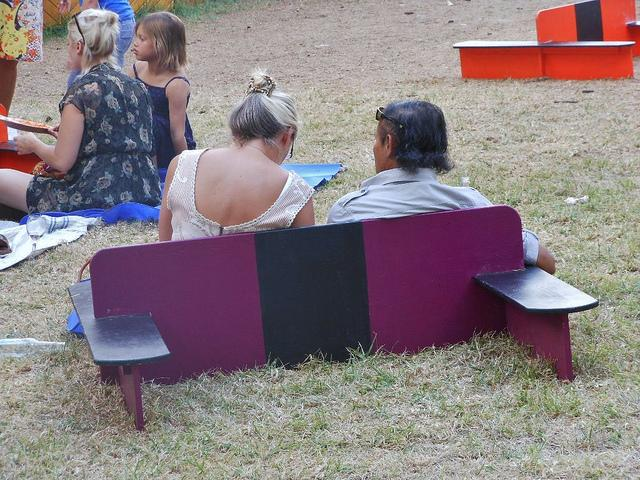Why are they so close together? Please explain your reasoning. friends. They're friends. 